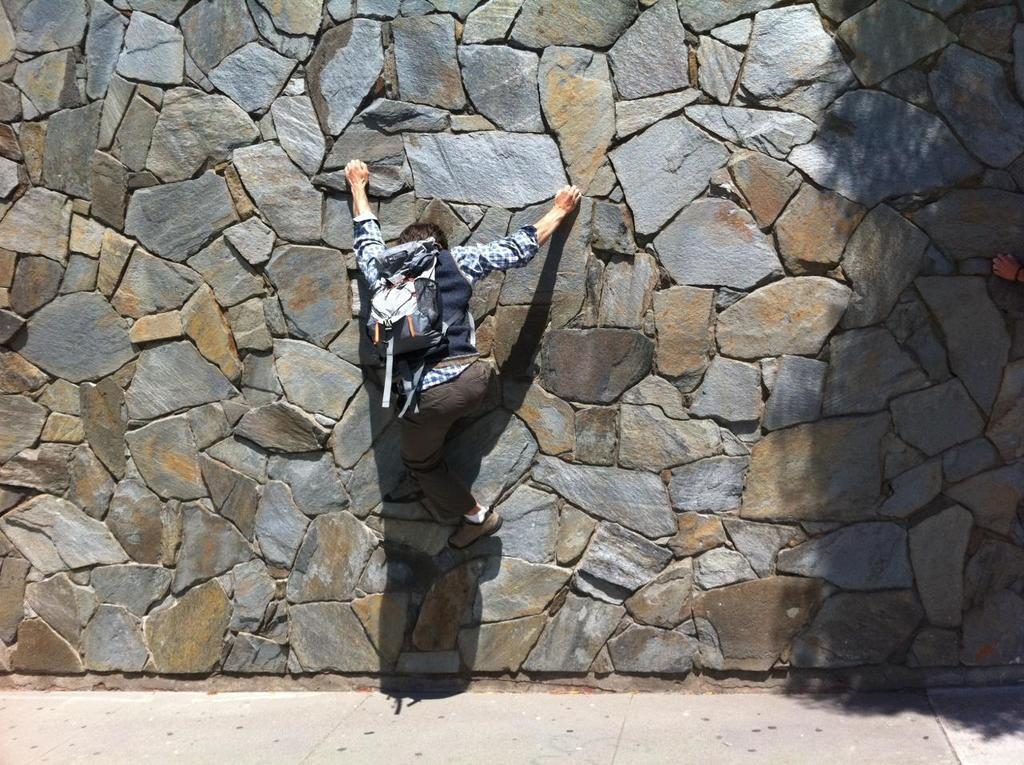Who is the main subject in the image? There is a boy in the image. Where is the boy located in the image? The boy is in the center of the image. What is the boy doing in the image? The boy is climbing a wall. What reward does the boy receive for climbing the wall in the image? There is no indication in the image that the boy receives a reward for climbing the wall. 